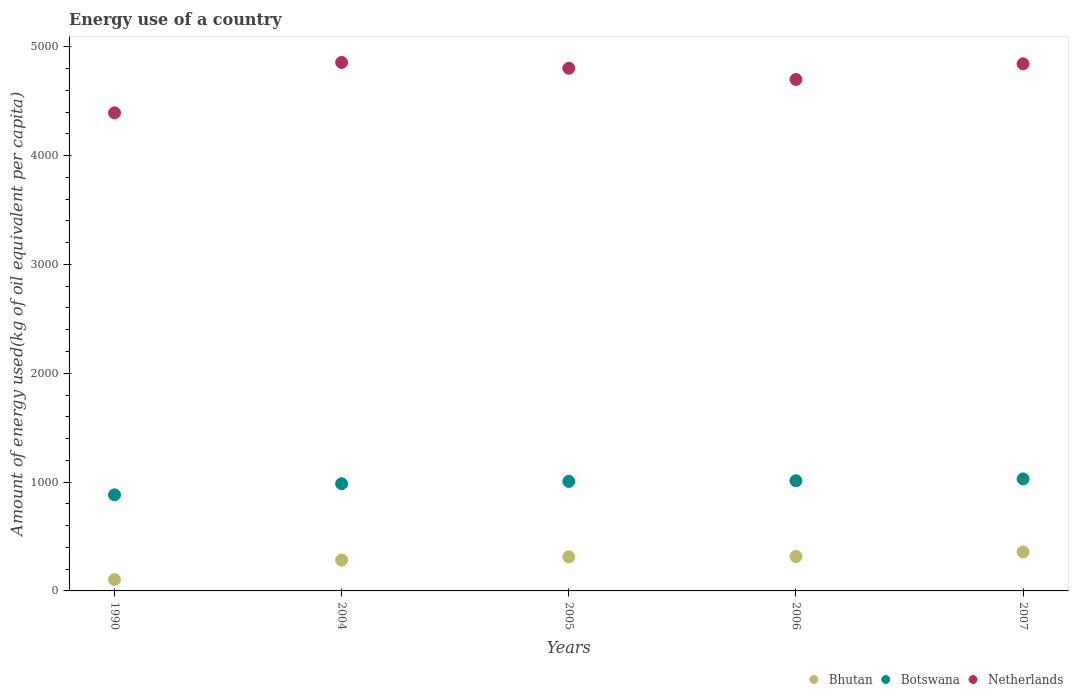Is the number of dotlines equal to the number of legend labels?
Give a very brief answer. Yes. What is the amount of energy used in in Botswana in 1990?
Your answer should be very brief. 882.94. Across all years, what is the maximum amount of energy used in in Bhutan?
Provide a short and direct response. 358.05. Across all years, what is the minimum amount of energy used in in Bhutan?
Provide a succinct answer. 104.53. In which year was the amount of energy used in in Netherlands maximum?
Your answer should be compact. 2004. What is the total amount of energy used in in Botswana in the graph?
Provide a short and direct response. 4916.44. What is the difference between the amount of energy used in in Botswana in 2004 and that in 2007?
Provide a short and direct response. -44.33. What is the difference between the amount of energy used in in Botswana in 2006 and the amount of energy used in in Netherlands in 2007?
Your answer should be compact. -3831.14. What is the average amount of energy used in in Bhutan per year?
Make the answer very short. 275.21. In the year 2006, what is the difference between the amount of energy used in in Netherlands and amount of energy used in in Botswana?
Give a very brief answer. 3687.53. What is the ratio of the amount of energy used in in Netherlands in 2004 to that in 2007?
Provide a succinct answer. 1. Is the amount of energy used in in Botswana in 1990 less than that in 2006?
Your answer should be compact. Yes. What is the difference between the highest and the second highest amount of energy used in in Netherlands?
Make the answer very short. 12.84. What is the difference between the highest and the lowest amount of energy used in in Botswana?
Keep it short and to the point. 146.35. In how many years, is the amount of energy used in in Bhutan greater than the average amount of energy used in in Bhutan taken over all years?
Make the answer very short. 4. Does the amount of energy used in in Botswana monotonically increase over the years?
Ensure brevity in your answer.  Yes. Is the amount of energy used in in Netherlands strictly greater than the amount of energy used in in Botswana over the years?
Make the answer very short. Yes. How many dotlines are there?
Keep it short and to the point. 3. Does the graph contain any zero values?
Give a very brief answer. No. Where does the legend appear in the graph?
Offer a very short reply. Bottom right. How are the legend labels stacked?
Keep it short and to the point. Horizontal. What is the title of the graph?
Offer a very short reply. Energy use of a country. Does "Kenya" appear as one of the legend labels in the graph?
Provide a succinct answer. No. What is the label or title of the Y-axis?
Ensure brevity in your answer.  Amount of energy used(kg of oil equivalent per capita). What is the Amount of energy used(kg of oil equivalent per capita) of Bhutan in 1990?
Offer a terse response. 104.53. What is the Amount of energy used(kg of oil equivalent per capita) in Botswana in 1990?
Ensure brevity in your answer.  882.94. What is the Amount of energy used(kg of oil equivalent per capita) in Netherlands in 1990?
Provide a short and direct response. 4393.2. What is the Amount of energy used(kg of oil equivalent per capita) of Bhutan in 2004?
Provide a short and direct response. 283.81. What is the Amount of energy used(kg of oil equivalent per capita) of Botswana in 2004?
Provide a short and direct response. 984.96. What is the Amount of energy used(kg of oil equivalent per capita) of Netherlands in 2004?
Provide a succinct answer. 4856.64. What is the Amount of energy used(kg of oil equivalent per capita) of Bhutan in 2005?
Your response must be concise. 313.29. What is the Amount of energy used(kg of oil equivalent per capita) in Botswana in 2005?
Ensure brevity in your answer.  1006.59. What is the Amount of energy used(kg of oil equivalent per capita) of Netherlands in 2005?
Provide a short and direct response. 4802.96. What is the Amount of energy used(kg of oil equivalent per capita) of Bhutan in 2006?
Provide a short and direct response. 316.38. What is the Amount of energy used(kg of oil equivalent per capita) in Botswana in 2006?
Offer a very short reply. 1012.65. What is the Amount of energy used(kg of oil equivalent per capita) of Netherlands in 2006?
Your response must be concise. 4700.18. What is the Amount of energy used(kg of oil equivalent per capita) in Bhutan in 2007?
Your answer should be very brief. 358.05. What is the Amount of energy used(kg of oil equivalent per capita) in Botswana in 2007?
Your response must be concise. 1029.29. What is the Amount of energy used(kg of oil equivalent per capita) of Netherlands in 2007?
Your response must be concise. 4843.8. Across all years, what is the maximum Amount of energy used(kg of oil equivalent per capita) in Bhutan?
Ensure brevity in your answer.  358.05. Across all years, what is the maximum Amount of energy used(kg of oil equivalent per capita) in Botswana?
Offer a terse response. 1029.29. Across all years, what is the maximum Amount of energy used(kg of oil equivalent per capita) of Netherlands?
Ensure brevity in your answer.  4856.64. Across all years, what is the minimum Amount of energy used(kg of oil equivalent per capita) of Bhutan?
Your answer should be compact. 104.53. Across all years, what is the minimum Amount of energy used(kg of oil equivalent per capita) in Botswana?
Your response must be concise. 882.94. Across all years, what is the minimum Amount of energy used(kg of oil equivalent per capita) of Netherlands?
Your answer should be compact. 4393.2. What is the total Amount of energy used(kg of oil equivalent per capita) of Bhutan in the graph?
Provide a succinct answer. 1376.05. What is the total Amount of energy used(kg of oil equivalent per capita) in Botswana in the graph?
Offer a very short reply. 4916.44. What is the total Amount of energy used(kg of oil equivalent per capita) of Netherlands in the graph?
Offer a terse response. 2.36e+04. What is the difference between the Amount of energy used(kg of oil equivalent per capita) of Bhutan in 1990 and that in 2004?
Keep it short and to the point. -179.28. What is the difference between the Amount of energy used(kg of oil equivalent per capita) of Botswana in 1990 and that in 2004?
Offer a very short reply. -102.02. What is the difference between the Amount of energy used(kg of oil equivalent per capita) of Netherlands in 1990 and that in 2004?
Keep it short and to the point. -463.44. What is the difference between the Amount of energy used(kg of oil equivalent per capita) in Bhutan in 1990 and that in 2005?
Offer a terse response. -208.76. What is the difference between the Amount of energy used(kg of oil equivalent per capita) of Botswana in 1990 and that in 2005?
Make the answer very short. -123.65. What is the difference between the Amount of energy used(kg of oil equivalent per capita) in Netherlands in 1990 and that in 2005?
Your answer should be very brief. -409.76. What is the difference between the Amount of energy used(kg of oil equivalent per capita) of Bhutan in 1990 and that in 2006?
Provide a succinct answer. -211.85. What is the difference between the Amount of energy used(kg of oil equivalent per capita) in Botswana in 1990 and that in 2006?
Your answer should be very brief. -129.71. What is the difference between the Amount of energy used(kg of oil equivalent per capita) of Netherlands in 1990 and that in 2006?
Your response must be concise. -306.98. What is the difference between the Amount of energy used(kg of oil equivalent per capita) in Bhutan in 1990 and that in 2007?
Keep it short and to the point. -253.52. What is the difference between the Amount of energy used(kg of oil equivalent per capita) in Botswana in 1990 and that in 2007?
Make the answer very short. -146.35. What is the difference between the Amount of energy used(kg of oil equivalent per capita) of Netherlands in 1990 and that in 2007?
Your response must be concise. -450.59. What is the difference between the Amount of energy used(kg of oil equivalent per capita) of Bhutan in 2004 and that in 2005?
Make the answer very short. -29.48. What is the difference between the Amount of energy used(kg of oil equivalent per capita) of Botswana in 2004 and that in 2005?
Ensure brevity in your answer.  -21.63. What is the difference between the Amount of energy used(kg of oil equivalent per capita) in Netherlands in 2004 and that in 2005?
Provide a short and direct response. 53.68. What is the difference between the Amount of energy used(kg of oil equivalent per capita) of Bhutan in 2004 and that in 2006?
Your answer should be very brief. -32.57. What is the difference between the Amount of energy used(kg of oil equivalent per capita) of Botswana in 2004 and that in 2006?
Keep it short and to the point. -27.69. What is the difference between the Amount of energy used(kg of oil equivalent per capita) of Netherlands in 2004 and that in 2006?
Your answer should be very brief. 156.46. What is the difference between the Amount of energy used(kg of oil equivalent per capita) of Bhutan in 2004 and that in 2007?
Offer a very short reply. -74.24. What is the difference between the Amount of energy used(kg of oil equivalent per capita) in Botswana in 2004 and that in 2007?
Provide a short and direct response. -44.33. What is the difference between the Amount of energy used(kg of oil equivalent per capita) of Netherlands in 2004 and that in 2007?
Your answer should be very brief. 12.84. What is the difference between the Amount of energy used(kg of oil equivalent per capita) in Bhutan in 2005 and that in 2006?
Provide a short and direct response. -3.09. What is the difference between the Amount of energy used(kg of oil equivalent per capita) of Botswana in 2005 and that in 2006?
Your answer should be compact. -6.06. What is the difference between the Amount of energy used(kg of oil equivalent per capita) of Netherlands in 2005 and that in 2006?
Your answer should be compact. 102.78. What is the difference between the Amount of energy used(kg of oil equivalent per capita) in Bhutan in 2005 and that in 2007?
Give a very brief answer. -44.76. What is the difference between the Amount of energy used(kg of oil equivalent per capita) of Botswana in 2005 and that in 2007?
Your answer should be very brief. -22.7. What is the difference between the Amount of energy used(kg of oil equivalent per capita) in Netherlands in 2005 and that in 2007?
Your answer should be compact. -40.84. What is the difference between the Amount of energy used(kg of oil equivalent per capita) in Bhutan in 2006 and that in 2007?
Your response must be concise. -41.67. What is the difference between the Amount of energy used(kg of oil equivalent per capita) in Botswana in 2006 and that in 2007?
Your response must be concise. -16.64. What is the difference between the Amount of energy used(kg of oil equivalent per capita) of Netherlands in 2006 and that in 2007?
Your answer should be compact. -143.61. What is the difference between the Amount of energy used(kg of oil equivalent per capita) in Bhutan in 1990 and the Amount of energy used(kg of oil equivalent per capita) in Botswana in 2004?
Keep it short and to the point. -880.43. What is the difference between the Amount of energy used(kg of oil equivalent per capita) of Bhutan in 1990 and the Amount of energy used(kg of oil equivalent per capita) of Netherlands in 2004?
Offer a very short reply. -4752.11. What is the difference between the Amount of energy used(kg of oil equivalent per capita) in Botswana in 1990 and the Amount of energy used(kg of oil equivalent per capita) in Netherlands in 2004?
Your response must be concise. -3973.7. What is the difference between the Amount of energy used(kg of oil equivalent per capita) of Bhutan in 1990 and the Amount of energy used(kg of oil equivalent per capita) of Botswana in 2005?
Make the answer very short. -902.06. What is the difference between the Amount of energy used(kg of oil equivalent per capita) in Bhutan in 1990 and the Amount of energy used(kg of oil equivalent per capita) in Netherlands in 2005?
Give a very brief answer. -4698.43. What is the difference between the Amount of energy used(kg of oil equivalent per capita) of Botswana in 1990 and the Amount of energy used(kg of oil equivalent per capita) of Netherlands in 2005?
Offer a terse response. -3920.02. What is the difference between the Amount of energy used(kg of oil equivalent per capita) of Bhutan in 1990 and the Amount of energy used(kg of oil equivalent per capita) of Botswana in 2006?
Offer a terse response. -908.13. What is the difference between the Amount of energy used(kg of oil equivalent per capita) in Bhutan in 1990 and the Amount of energy used(kg of oil equivalent per capita) in Netherlands in 2006?
Provide a short and direct response. -4595.66. What is the difference between the Amount of energy used(kg of oil equivalent per capita) in Botswana in 1990 and the Amount of energy used(kg of oil equivalent per capita) in Netherlands in 2006?
Ensure brevity in your answer.  -3817.24. What is the difference between the Amount of energy used(kg of oil equivalent per capita) of Bhutan in 1990 and the Amount of energy used(kg of oil equivalent per capita) of Botswana in 2007?
Offer a terse response. -924.76. What is the difference between the Amount of energy used(kg of oil equivalent per capita) in Bhutan in 1990 and the Amount of energy used(kg of oil equivalent per capita) in Netherlands in 2007?
Provide a short and direct response. -4739.27. What is the difference between the Amount of energy used(kg of oil equivalent per capita) of Botswana in 1990 and the Amount of energy used(kg of oil equivalent per capita) of Netherlands in 2007?
Your answer should be compact. -3960.86. What is the difference between the Amount of energy used(kg of oil equivalent per capita) of Bhutan in 2004 and the Amount of energy used(kg of oil equivalent per capita) of Botswana in 2005?
Your answer should be compact. -722.79. What is the difference between the Amount of energy used(kg of oil equivalent per capita) in Bhutan in 2004 and the Amount of energy used(kg of oil equivalent per capita) in Netherlands in 2005?
Offer a terse response. -4519.15. What is the difference between the Amount of energy used(kg of oil equivalent per capita) in Botswana in 2004 and the Amount of energy used(kg of oil equivalent per capita) in Netherlands in 2005?
Give a very brief answer. -3818. What is the difference between the Amount of energy used(kg of oil equivalent per capita) in Bhutan in 2004 and the Amount of energy used(kg of oil equivalent per capita) in Botswana in 2006?
Give a very brief answer. -728.85. What is the difference between the Amount of energy used(kg of oil equivalent per capita) in Bhutan in 2004 and the Amount of energy used(kg of oil equivalent per capita) in Netherlands in 2006?
Provide a short and direct response. -4416.38. What is the difference between the Amount of energy used(kg of oil equivalent per capita) in Botswana in 2004 and the Amount of energy used(kg of oil equivalent per capita) in Netherlands in 2006?
Keep it short and to the point. -3715.22. What is the difference between the Amount of energy used(kg of oil equivalent per capita) of Bhutan in 2004 and the Amount of energy used(kg of oil equivalent per capita) of Botswana in 2007?
Offer a very short reply. -745.48. What is the difference between the Amount of energy used(kg of oil equivalent per capita) of Bhutan in 2004 and the Amount of energy used(kg of oil equivalent per capita) of Netherlands in 2007?
Your answer should be very brief. -4559.99. What is the difference between the Amount of energy used(kg of oil equivalent per capita) of Botswana in 2004 and the Amount of energy used(kg of oil equivalent per capita) of Netherlands in 2007?
Provide a succinct answer. -3858.83. What is the difference between the Amount of energy used(kg of oil equivalent per capita) in Bhutan in 2005 and the Amount of energy used(kg of oil equivalent per capita) in Botswana in 2006?
Ensure brevity in your answer.  -699.37. What is the difference between the Amount of energy used(kg of oil equivalent per capita) in Bhutan in 2005 and the Amount of energy used(kg of oil equivalent per capita) in Netherlands in 2006?
Provide a succinct answer. -4386.9. What is the difference between the Amount of energy used(kg of oil equivalent per capita) in Botswana in 2005 and the Amount of energy used(kg of oil equivalent per capita) in Netherlands in 2006?
Ensure brevity in your answer.  -3693.59. What is the difference between the Amount of energy used(kg of oil equivalent per capita) of Bhutan in 2005 and the Amount of energy used(kg of oil equivalent per capita) of Botswana in 2007?
Make the answer very short. -716. What is the difference between the Amount of energy used(kg of oil equivalent per capita) in Bhutan in 2005 and the Amount of energy used(kg of oil equivalent per capita) in Netherlands in 2007?
Ensure brevity in your answer.  -4530.51. What is the difference between the Amount of energy used(kg of oil equivalent per capita) of Botswana in 2005 and the Amount of energy used(kg of oil equivalent per capita) of Netherlands in 2007?
Ensure brevity in your answer.  -3837.2. What is the difference between the Amount of energy used(kg of oil equivalent per capita) in Bhutan in 2006 and the Amount of energy used(kg of oil equivalent per capita) in Botswana in 2007?
Provide a succinct answer. -712.91. What is the difference between the Amount of energy used(kg of oil equivalent per capita) in Bhutan in 2006 and the Amount of energy used(kg of oil equivalent per capita) in Netherlands in 2007?
Provide a short and direct response. -4527.42. What is the difference between the Amount of energy used(kg of oil equivalent per capita) in Botswana in 2006 and the Amount of energy used(kg of oil equivalent per capita) in Netherlands in 2007?
Offer a very short reply. -3831.14. What is the average Amount of energy used(kg of oil equivalent per capita) in Bhutan per year?
Your answer should be compact. 275.21. What is the average Amount of energy used(kg of oil equivalent per capita) in Botswana per year?
Your answer should be very brief. 983.29. What is the average Amount of energy used(kg of oil equivalent per capita) in Netherlands per year?
Keep it short and to the point. 4719.36. In the year 1990, what is the difference between the Amount of energy used(kg of oil equivalent per capita) of Bhutan and Amount of energy used(kg of oil equivalent per capita) of Botswana?
Your answer should be compact. -778.41. In the year 1990, what is the difference between the Amount of energy used(kg of oil equivalent per capita) in Bhutan and Amount of energy used(kg of oil equivalent per capita) in Netherlands?
Offer a very short reply. -4288.68. In the year 1990, what is the difference between the Amount of energy used(kg of oil equivalent per capita) of Botswana and Amount of energy used(kg of oil equivalent per capita) of Netherlands?
Your response must be concise. -3510.26. In the year 2004, what is the difference between the Amount of energy used(kg of oil equivalent per capita) in Bhutan and Amount of energy used(kg of oil equivalent per capita) in Botswana?
Offer a very short reply. -701.16. In the year 2004, what is the difference between the Amount of energy used(kg of oil equivalent per capita) of Bhutan and Amount of energy used(kg of oil equivalent per capita) of Netherlands?
Offer a very short reply. -4572.83. In the year 2004, what is the difference between the Amount of energy used(kg of oil equivalent per capita) of Botswana and Amount of energy used(kg of oil equivalent per capita) of Netherlands?
Ensure brevity in your answer.  -3871.68. In the year 2005, what is the difference between the Amount of energy used(kg of oil equivalent per capita) in Bhutan and Amount of energy used(kg of oil equivalent per capita) in Botswana?
Your answer should be compact. -693.31. In the year 2005, what is the difference between the Amount of energy used(kg of oil equivalent per capita) of Bhutan and Amount of energy used(kg of oil equivalent per capita) of Netherlands?
Make the answer very short. -4489.67. In the year 2005, what is the difference between the Amount of energy used(kg of oil equivalent per capita) of Botswana and Amount of energy used(kg of oil equivalent per capita) of Netherlands?
Your response must be concise. -3796.37. In the year 2006, what is the difference between the Amount of energy used(kg of oil equivalent per capita) in Bhutan and Amount of energy used(kg of oil equivalent per capita) in Botswana?
Ensure brevity in your answer.  -696.27. In the year 2006, what is the difference between the Amount of energy used(kg of oil equivalent per capita) of Bhutan and Amount of energy used(kg of oil equivalent per capita) of Netherlands?
Offer a terse response. -4383.8. In the year 2006, what is the difference between the Amount of energy used(kg of oil equivalent per capita) of Botswana and Amount of energy used(kg of oil equivalent per capita) of Netherlands?
Keep it short and to the point. -3687.53. In the year 2007, what is the difference between the Amount of energy used(kg of oil equivalent per capita) in Bhutan and Amount of energy used(kg of oil equivalent per capita) in Botswana?
Offer a very short reply. -671.24. In the year 2007, what is the difference between the Amount of energy used(kg of oil equivalent per capita) in Bhutan and Amount of energy used(kg of oil equivalent per capita) in Netherlands?
Keep it short and to the point. -4485.75. In the year 2007, what is the difference between the Amount of energy used(kg of oil equivalent per capita) of Botswana and Amount of energy used(kg of oil equivalent per capita) of Netherlands?
Your answer should be very brief. -3814.51. What is the ratio of the Amount of energy used(kg of oil equivalent per capita) in Bhutan in 1990 to that in 2004?
Offer a very short reply. 0.37. What is the ratio of the Amount of energy used(kg of oil equivalent per capita) in Botswana in 1990 to that in 2004?
Your response must be concise. 0.9. What is the ratio of the Amount of energy used(kg of oil equivalent per capita) in Netherlands in 1990 to that in 2004?
Ensure brevity in your answer.  0.9. What is the ratio of the Amount of energy used(kg of oil equivalent per capita) of Bhutan in 1990 to that in 2005?
Your answer should be compact. 0.33. What is the ratio of the Amount of energy used(kg of oil equivalent per capita) in Botswana in 1990 to that in 2005?
Provide a short and direct response. 0.88. What is the ratio of the Amount of energy used(kg of oil equivalent per capita) of Netherlands in 1990 to that in 2005?
Your response must be concise. 0.91. What is the ratio of the Amount of energy used(kg of oil equivalent per capita) of Bhutan in 1990 to that in 2006?
Give a very brief answer. 0.33. What is the ratio of the Amount of energy used(kg of oil equivalent per capita) of Botswana in 1990 to that in 2006?
Ensure brevity in your answer.  0.87. What is the ratio of the Amount of energy used(kg of oil equivalent per capita) of Netherlands in 1990 to that in 2006?
Give a very brief answer. 0.93. What is the ratio of the Amount of energy used(kg of oil equivalent per capita) of Bhutan in 1990 to that in 2007?
Your answer should be compact. 0.29. What is the ratio of the Amount of energy used(kg of oil equivalent per capita) in Botswana in 1990 to that in 2007?
Ensure brevity in your answer.  0.86. What is the ratio of the Amount of energy used(kg of oil equivalent per capita) in Netherlands in 1990 to that in 2007?
Your answer should be compact. 0.91. What is the ratio of the Amount of energy used(kg of oil equivalent per capita) of Bhutan in 2004 to that in 2005?
Make the answer very short. 0.91. What is the ratio of the Amount of energy used(kg of oil equivalent per capita) of Botswana in 2004 to that in 2005?
Provide a short and direct response. 0.98. What is the ratio of the Amount of energy used(kg of oil equivalent per capita) in Netherlands in 2004 to that in 2005?
Offer a very short reply. 1.01. What is the ratio of the Amount of energy used(kg of oil equivalent per capita) in Bhutan in 2004 to that in 2006?
Provide a short and direct response. 0.9. What is the ratio of the Amount of energy used(kg of oil equivalent per capita) in Botswana in 2004 to that in 2006?
Your answer should be compact. 0.97. What is the ratio of the Amount of energy used(kg of oil equivalent per capita) of Netherlands in 2004 to that in 2006?
Offer a very short reply. 1.03. What is the ratio of the Amount of energy used(kg of oil equivalent per capita) in Bhutan in 2004 to that in 2007?
Offer a terse response. 0.79. What is the ratio of the Amount of energy used(kg of oil equivalent per capita) of Botswana in 2004 to that in 2007?
Your response must be concise. 0.96. What is the ratio of the Amount of energy used(kg of oil equivalent per capita) of Bhutan in 2005 to that in 2006?
Your answer should be compact. 0.99. What is the ratio of the Amount of energy used(kg of oil equivalent per capita) in Netherlands in 2005 to that in 2006?
Your answer should be compact. 1.02. What is the ratio of the Amount of energy used(kg of oil equivalent per capita) in Botswana in 2005 to that in 2007?
Your answer should be very brief. 0.98. What is the ratio of the Amount of energy used(kg of oil equivalent per capita) of Netherlands in 2005 to that in 2007?
Your response must be concise. 0.99. What is the ratio of the Amount of energy used(kg of oil equivalent per capita) of Bhutan in 2006 to that in 2007?
Provide a succinct answer. 0.88. What is the ratio of the Amount of energy used(kg of oil equivalent per capita) in Botswana in 2006 to that in 2007?
Your response must be concise. 0.98. What is the ratio of the Amount of energy used(kg of oil equivalent per capita) of Netherlands in 2006 to that in 2007?
Offer a terse response. 0.97. What is the difference between the highest and the second highest Amount of energy used(kg of oil equivalent per capita) in Bhutan?
Keep it short and to the point. 41.67. What is the difference between the highest and the second highest Amount of energy used(kg of oil equivalent per capita) in Botswana?
Your response must be concise. 16.64. What is the difference between the highest and the second highest Amount of energy used(kg of oil equivalent per capita) in Netherlands?
Ensure brevity in your answer.  12.84. What is the difference between the highest and the lowest Amount of energy used(kg of oil equivalent per capita) in Bhutan?
Make the answer very short. 253.52. What is the difference between the highest and the lowest Amount of energy used(kg of oil equivalent per capita) of Botswana?
Provide a succinct answer. 146.35. What is the difference between the highest and the lowest Amount of energy used(kg of oil equivalent per capita) of Netherlands?
Ensure brevity in your answer.  463.44. 